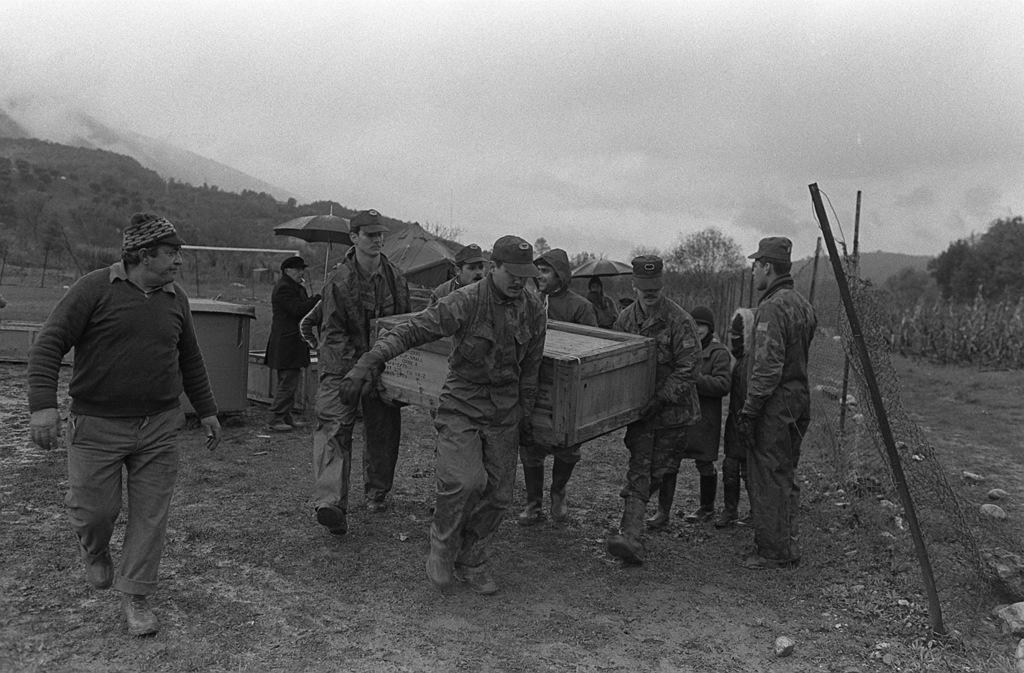How many people are in the group visible in the image? There is a group of people in the image, but the exact number is not specified. What are some people in the group doing? Some people in the group are carrying boxes. What can be seen in the background of the image? In the background of the image, there are mountains, the sky, and clouds. What might be used for protection from rain or sun in the image? Umbrellas are present in the image for protection from rain or sun. What type of vegetation is visible in the image? Trees are visible in the image. What language is being spoken by the people in the image? The provided facts do not mention any specific language being spoken by the people in the image. Is the image depicting a fictional scene or a real-life situation? The provided facts do not indicate whether the image is depicting a fictional scene or a real-life situation. 